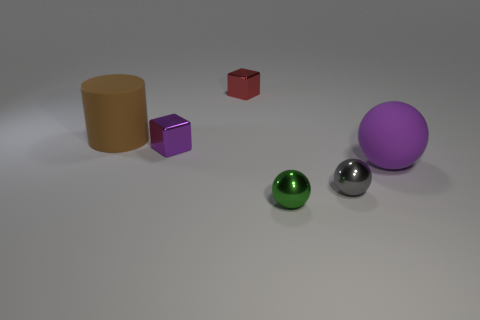What number of things are in front of the brown cylinder and left of the red object?
Offer a very short reply. 1. What color is the tiny block that is behind the cube that is in front of the big brown rubber cylinder?
Make the answer very short. Red. Are there an equal number of gray objects behind the small purple cube and tiny brown objects?
Your answer should be compact. Yes. There is a big thing on the left side of the tiny sphere behind the green object; how many tiny metallic objects are left of it?
Make the answer very short. 0. The sphere left of the gray metallic sphere is what color?
Offer a very short reply. Green. There is a tiny object that is both in front of the purple metal object and behind the small green metal object; what material is it made of?
Your answer should be very brief. Metal. How many tiny red things are right of the rubber object that is behind the large rubber ball?
Provide a short and direct response. 1. There is a red metallic object; what shape is it?
Give a very brief answer. Cube. The purple object that is made of the same material as the small red cube is what shape?
Offer a very short reply. Cube. Do the large rubber thing that is right of the gray sphere and the big brown rubber object have the same shape?
Your response must be concise. No. 